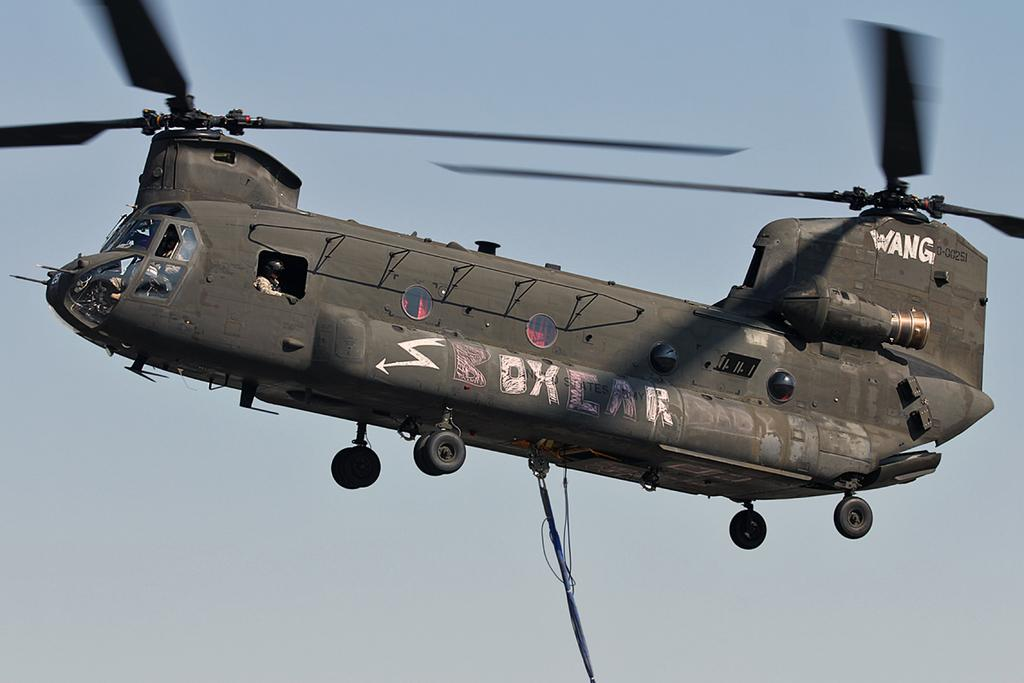<image>
Give a short and clear explanation of the subsequent image. A military chopper in flight shows its graffiti that says "boxcar." 